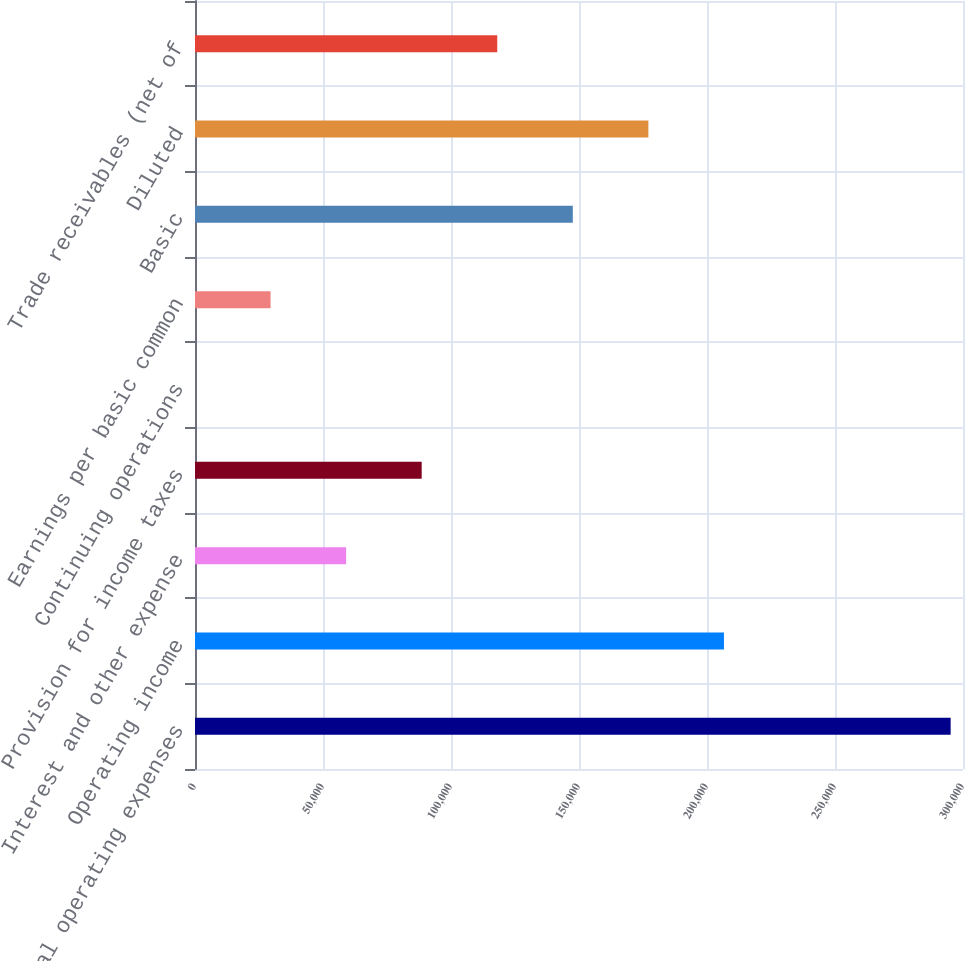<chart> <loc_0><loc_0><loc_500><loc_500><bar_chart><fcel>Total operating expenses<fcel>Operating income<fcel>Interest and other expense<fcel>Provision for income taxes<fcel>Continuing operations<fcel>Earnings per basic common<fcel>Basic<fcel>Diluted<fcel>Trade receivables (net of<nl><fcel>295171<fcel>206620<fcel>59034.7<fcel>88551.8<fcel>0.68<fcel>29517.7<fcel>147586<fcel>177103<fcel>118069<nl></chart> 